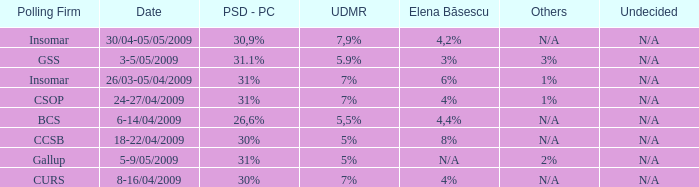What is the elena basescu when the poling firm of gallup? N/A. 